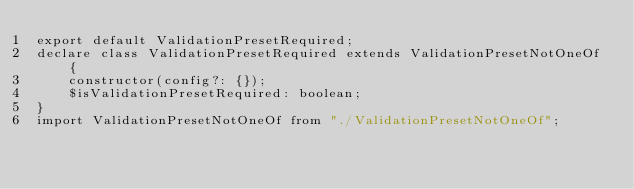<code> <loc_0><loc_0><loc_500><loc_500><_TypeScript_>export default ValidationPresetRequired;
declare class ValidationPresetRequired extends ValidationPresetNotOneOf {
    constructor(config?: {});
    $isValidationPresetRequired: boolean;
}
import ValidationPresetNotOneOf from "./ValidationPresetNotOneOf";
</code> 